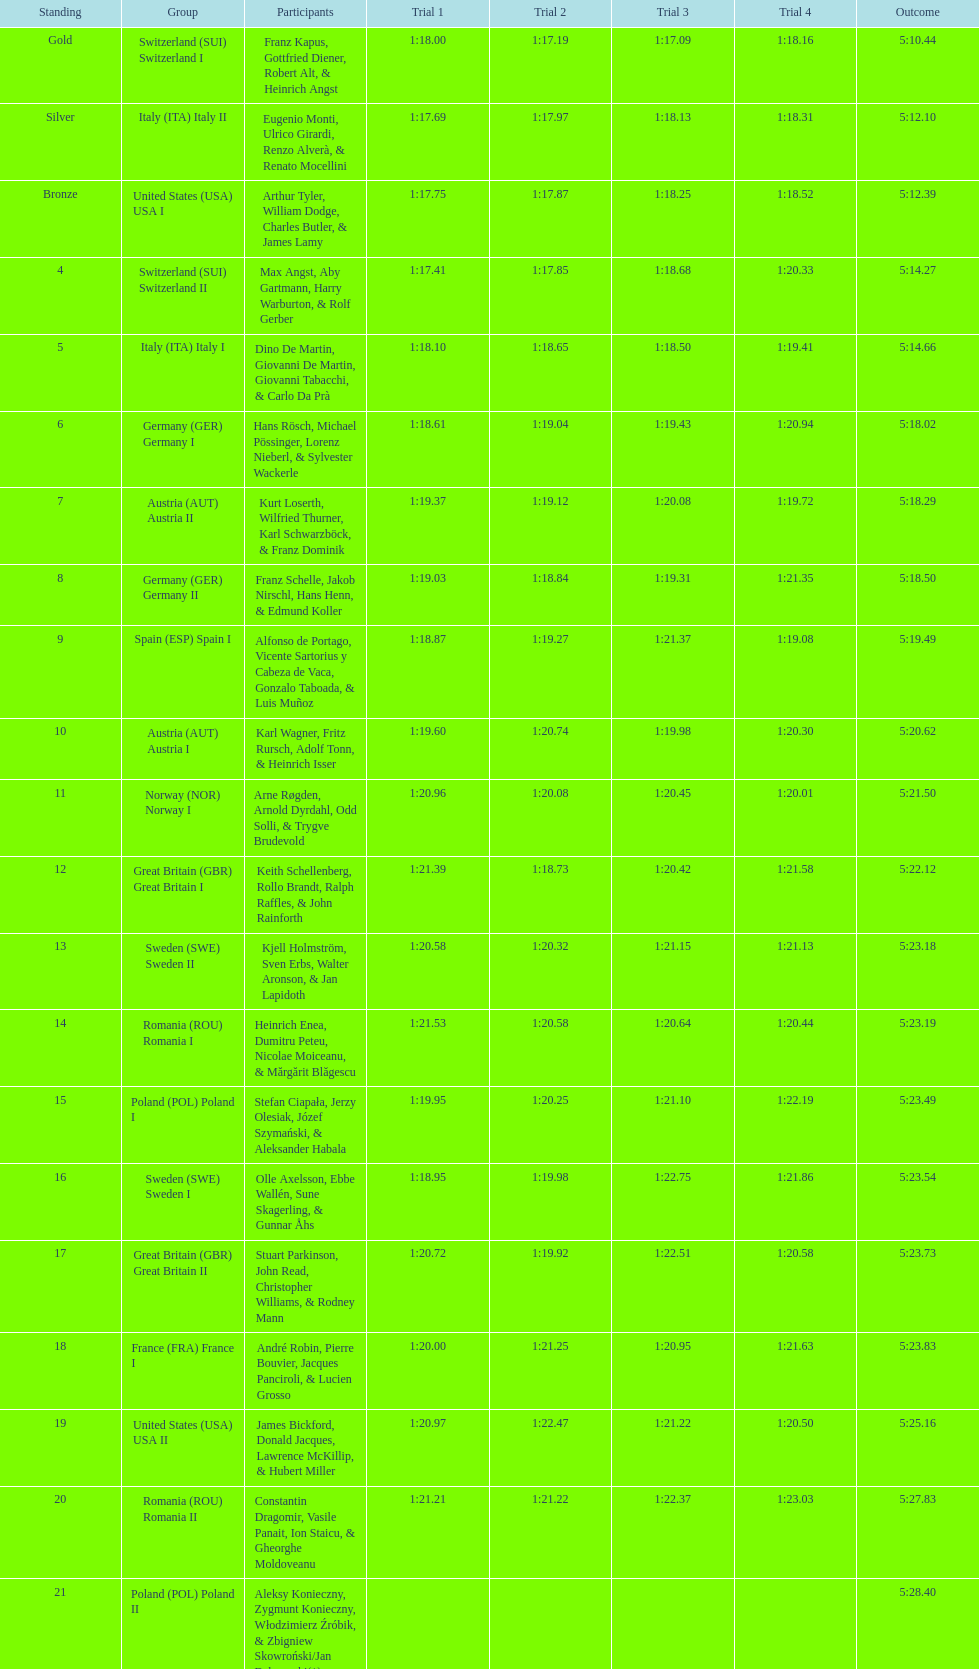What is the total amount of runs? 4. 